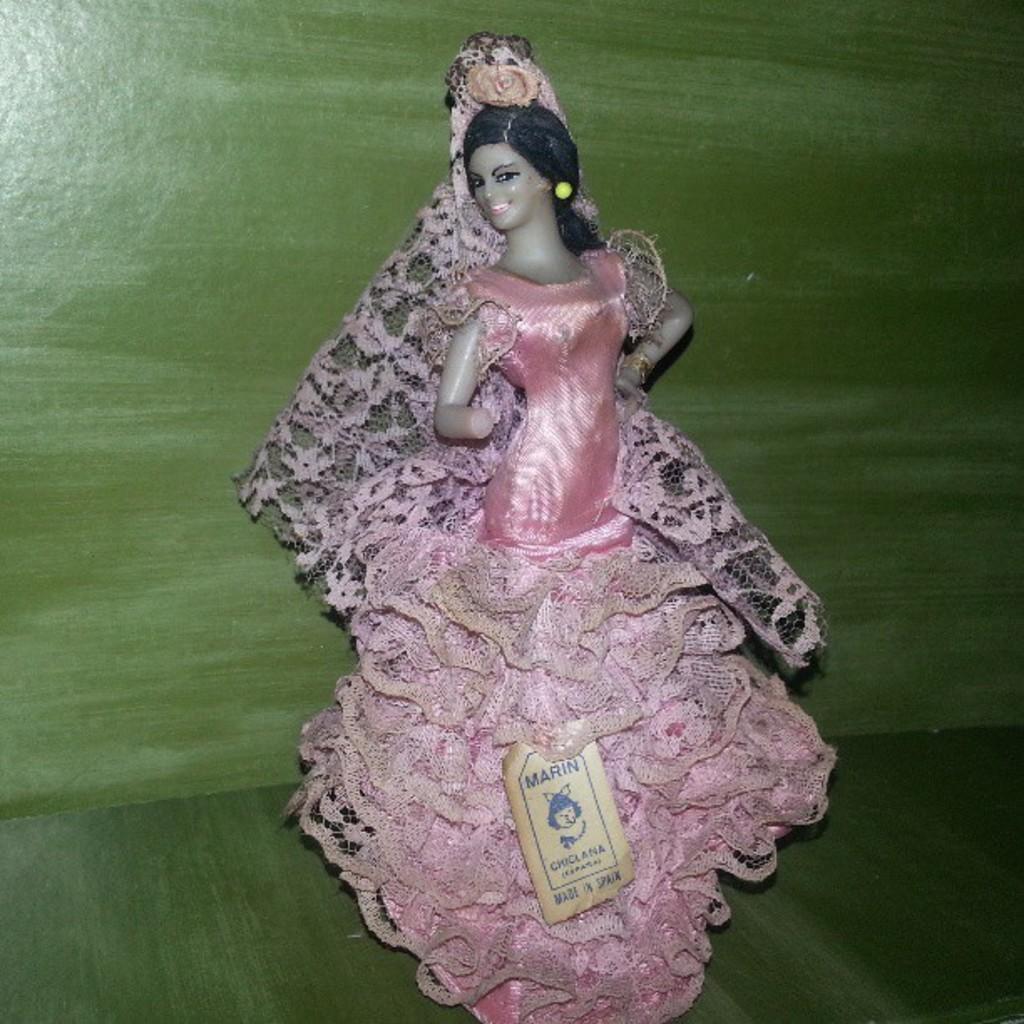In one or two sentences, can you explain what this image depicts? In the picture we can see a doll of a girl child which is in a pink dress and behind it, we can see a wall which is green in color. 